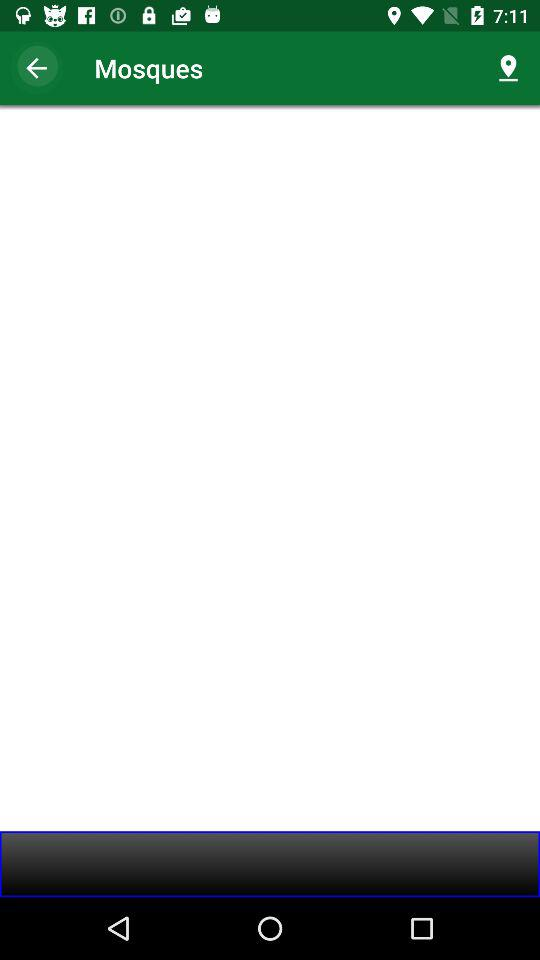For which prayer times have notifications been enabled? The notifications have been enabled for "Fajr", "Dhuhr", "Asr", "Maghrib" and "Isha'a". 